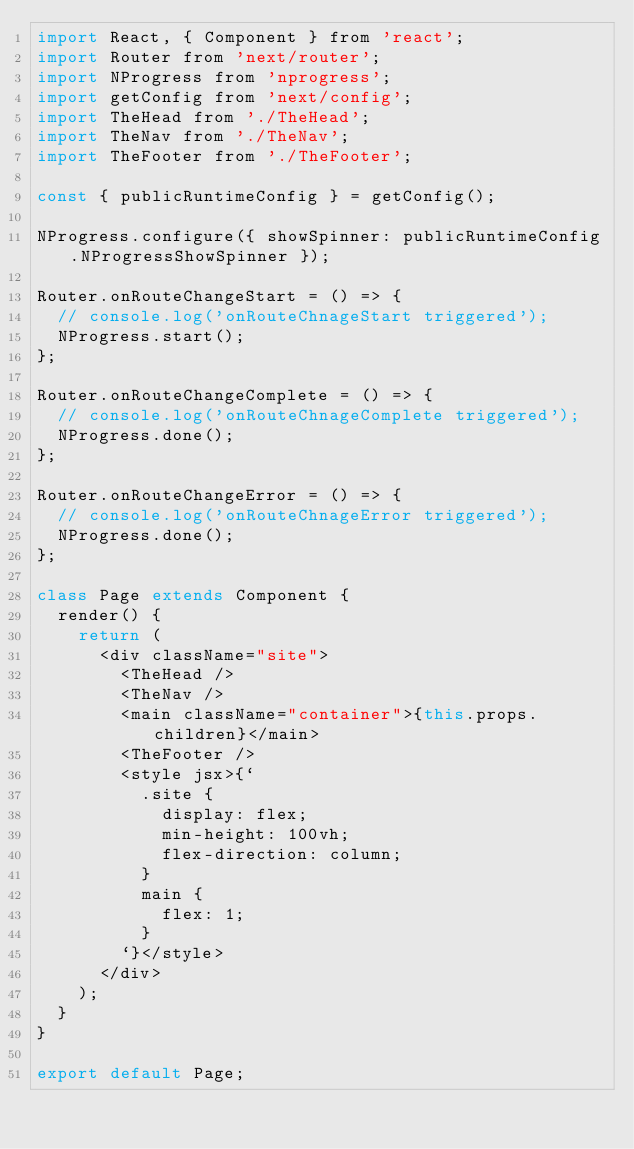Convert code to text. <code><loc_0><loc_0><loc_500><loc_500><_JavaScript_>import React, { Component } from 'react';
import Router from 'next/router';
import NProgress from 'nprogress';
import getConfig from 'next/config';
import TheHead from './TheHead';
import TheNav from './TheNav';
import TheFooter from './TheFooter';

const { publicRuntimeConfig } = getConfig();

NProgress.configure({ showSpinner: publicRuntimeConfig.NProgressShowSpinner });

Router.onRouteChangeStart = () => {
  // console.log('onRouteChnageStart triggered');
  NProgress.start();
};

Router.onRouteChangeComplete = () => {
  // console.log('onRouteChnageComplete triggered');
  NProgress.done();
};

Router.onRouteChangeError = () => {
  // console.log('onRouteChnageError triggered');
  NProgress.done();
};

class Page extends Component {
  render() {
    return (
      <div className="site">
        <TheHead />
        <TheNav />
        <main className="container">{this.props.children}</main>
        <TheFooter />
        <style jsx>{`
          .site {
            display: flex;
            min-height: 100vh;
            flex-direction: column;
          }
          main {
            flex: 1;
          }
        `}</style>
      </div>
    );
  }
}

export default Page;
</code> 